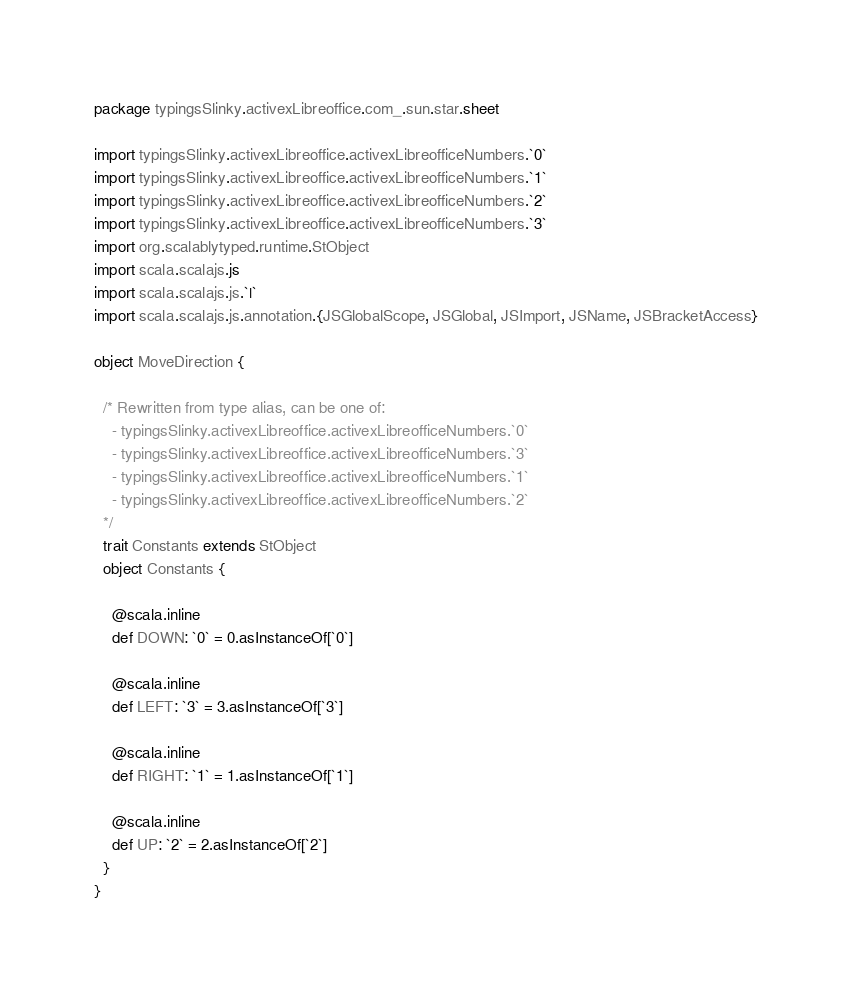Convert code to text. <code><loc_0><loc_0><loc_500><loc_500><_Scala_>package typingsSlinky.activexLibreoffice.com_.sun.star.sheet

import typingsSlinky.activexLibreoffice.activexLibreofficeNumbers.`0`
import typingsSlinky.activexLibreoffice.activexLibreofficeNumbers.`1`
import typingsSlinky.activexLibreoffice.activexLibreofficeNumbers.`2`
import typingsSlinky.activexLibreoffice.activexLibreofficeNumbers.`3`
import org.scalablytyped.runtime.StObject
import scala.scalajs.js
import scala.scalajs.js.`|`
import scala.scalajs.js.annotation.{JSGlobalScope, JSGlobal, JSImport, JSName, JSBracketAccess}

object MoveDirection {
  
  /* Rewritten from type alias, can be one of: 
    - typingsSlinky.activexLibreoffice.activexLibreofficeNumbers.`0`
    - typingsSlinky.activexLibreoffice.activexLibreofficeNumbers.`3`
    - typingsSlinky.activexLibreoffice.activexLibreofficeNumbers.`1`
    - typingsSlinky.activexLibreoffice.activexLibreofficeNumbers.`2`
  */
  trait Constants extends StObject
  object Constants {
    
    @scala.inline
    def DOWN: `0` = 0.asInstanceOf[`0`]
    
    @scala.inline
    def LEFT: `3` = 3.asInstanceOf[`3`]
    
    @scala.inline
    def RIGHT: `1` = 1.asInstanceOf[`1`]
    
    @scala.inline
    def UP: `2` = 2.asInstanceOf[`2`]
  }
}
</code> 